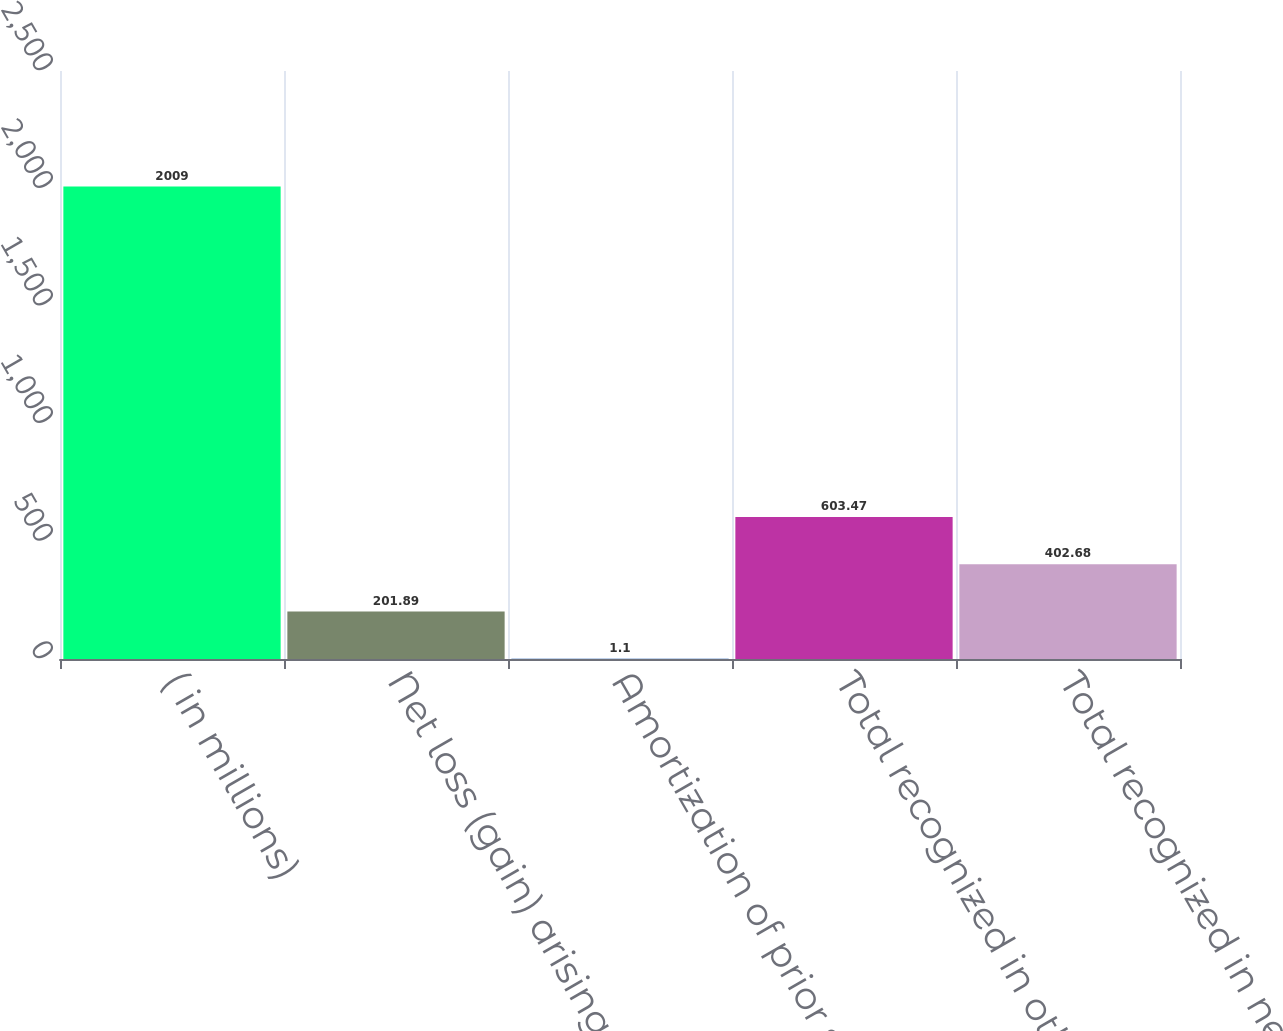<chart> <loc_0><loc_0><loc_500><loc_500><bar_chart><fcel>( in millions)<fcel>Net loss (gain) arising during<fcel>Amortization of prior service<fcel>Total recognized in other<fcel>Total recognized in net<nl><fcel>2009<fcel>201.89<fcel>1.1<fcel>603.47<fcel>402.68<nl></chart> 